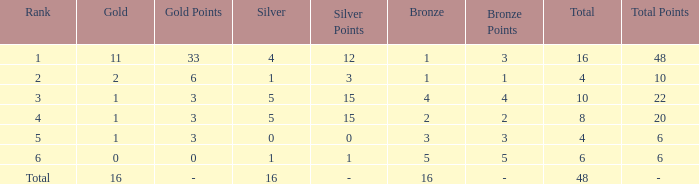How many gold are a rank 1 and larger than 16? 0.0. 